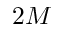<formula> <loc_0><loc_0><loc_500><loc_500>2 M</formula> 